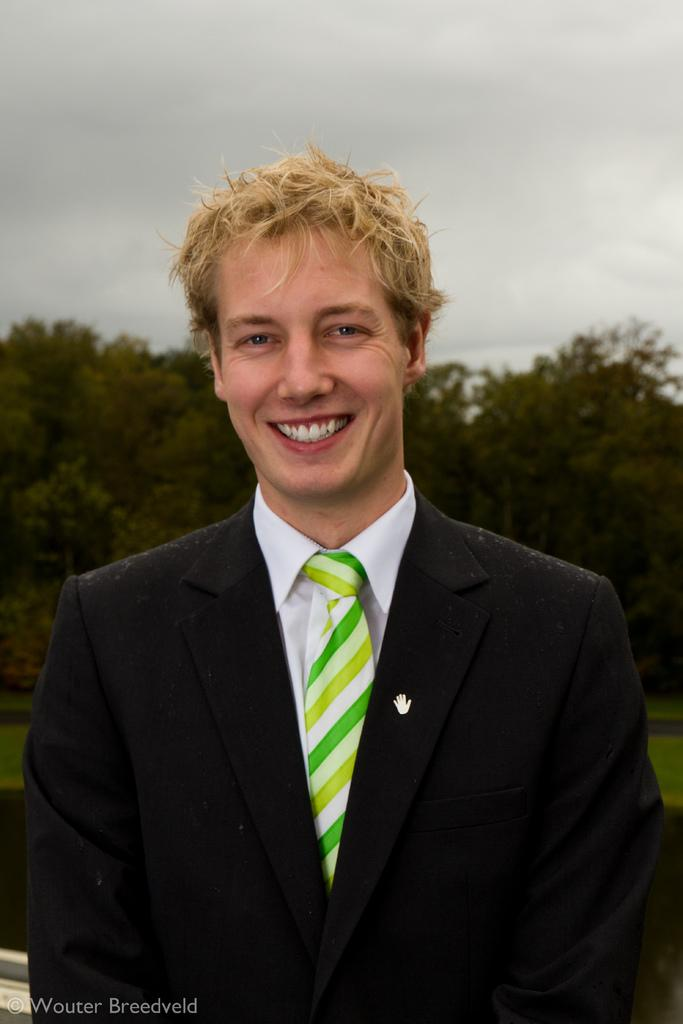What is the main subject of the image? There is a person in the image. How is the person dressed? The person is wearing a coat and tie. What can be found at the bottom of the image? There is text at the bottom of the image. What type of natural scenery is visible in the background? There is a group of trees in the background of the image. What else can be seen in the background? The sky is visible in the background of the image. What type of connection does the person have with the song playing in the background? There is no song playing in the background of the image, so it is not possible to determine any connection between the person and a song. 